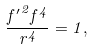<formula> <loc_0><loc_0><loc_500><loc_500>\frac { { f ^ { \prime } } ^ { 2 } f ^ { 4 } } { r ^ { 4 } } = 1 ,</formula> 